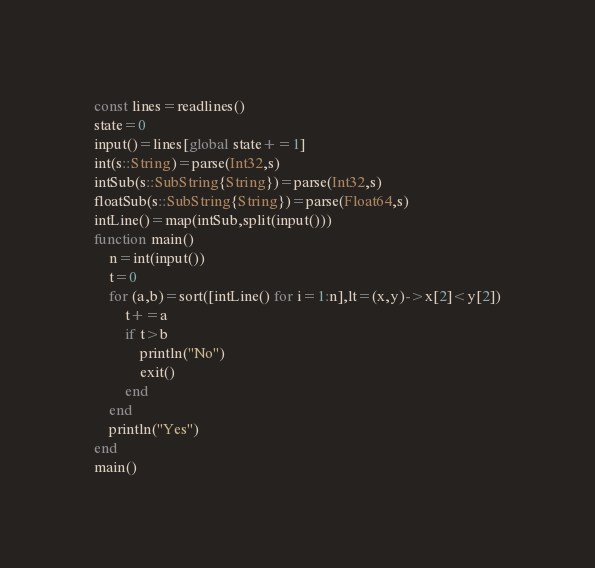Convert code to text. <code><loc_0><loc_0><loc_500><loc_500><_Julia_>const lines=readlines()
state=0
input()=lines[global state+=1]
int(s::String)=parse(Int32,s)
intSub(s::SubString{String})=parse(Int32,s)
floatSub(s::SubString{String})=parse(Float64,s)
intLine()=map(intSub,split(input()))
function main()
    n=int(input())
    t=0
    for (a,b)=sort([intLine() for i=1:n],lt=(x,y)->x[2]<y[2])
        t+=a
        if t>b
            println("No")
            exit()
        end
    end
    println("Yes")
end
main()</code> 